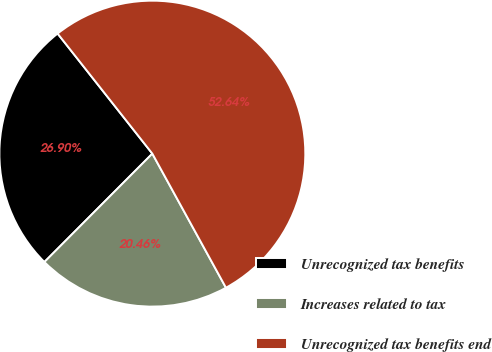Convert chart to OTSL. <chart><loc_0><loc_0><loc_500><loc_500><pie_chart><fcel>Unrecognized tax benefits<fcel>Increases related to tax<fcel>Unrecognized tax benefits end<nl><fcel>26.9%<fcel>20.46%<fcel>52.64%<nl></chart> 